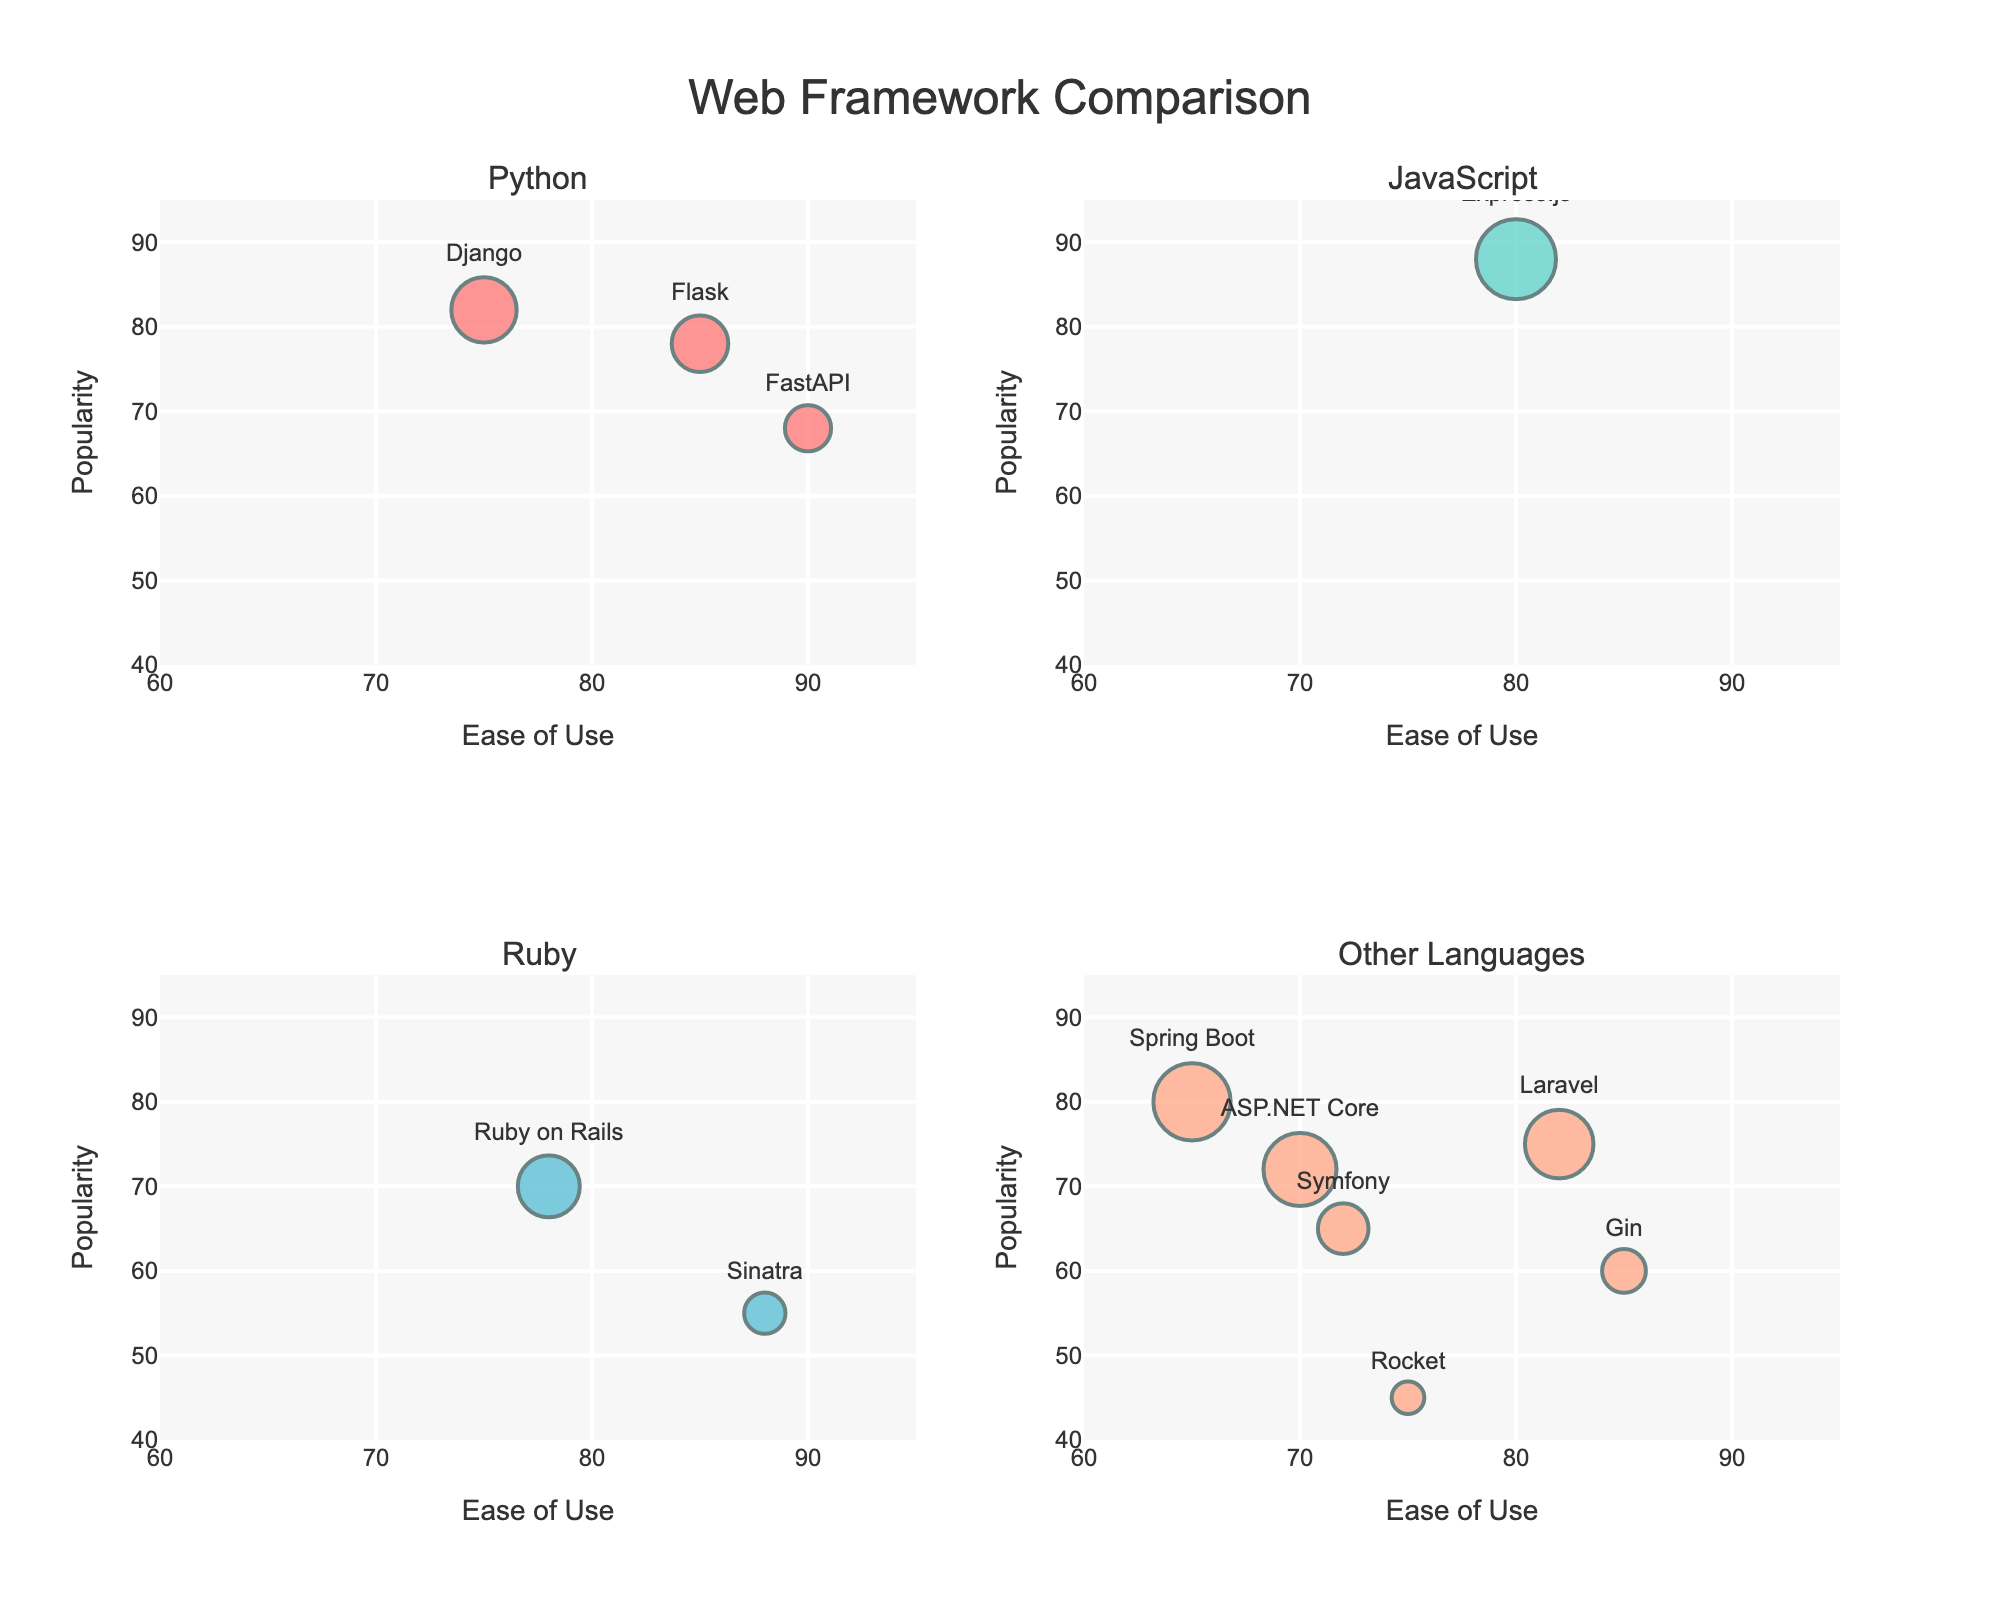What is the title of the figure? The title is located at the top center of the figure. It states the main topic represented by the visual data.
Answer: Web Framework Comparison Which frameworks are grouped under the Ruby language? In the subplot titled 'Ruby', identify the text labels inside the bubbles.
Answer: Ruby on Rails, Sinatra Among the frameworks using Python, which has the highest ease of use? In the subplot titled 'Python', compare ease-of-use values by looking at the x-axis positions.
Answer: FastAPI Which framework has the largest bubble in the JavaScript subplot? Locate the subplot titled 'JavaScript' and identify the framework with the largest bubble, indicating the largest community size.
Answer: Express.js What is the relationship between ease of use and popularity for Django? Find Django in the subplot titled 'Python' and note its x-axis (ease of use) and y-axis (popularity) positions to describe the relationship.
Answer: Ease of use: 75, Popularity: 82 How does Flask's community size compare to Laravel's? Compare the size of the bubbles representing Flask in the 'Python' subplot and Laravel in the 'Other Languages' subplot by referring to the size description.
Answer: Flask's community size is smaller than Laravel's Which framework has the lowest popularity in all subplots? Identify the bubble that is lowest on the y-axis across all subplots.
Answer: Rocket How are frameworks categorized in the figure? Describe the criteria used to plot frameworks in different subplots based on their programming language.
Answer: By programming language: Python, JavaScript, Ruby, and other languages Which of the Ruby frameworks has a higher ease of use? Compare the x-axis positions of Ruby on Rails and Sinatra in the 'Ruby' subplot.
Answer: Sinatra What is the general trend between community size and bubble size? Describe how the size of bubbles varies with the community size based on the visual representation.
Answer: Larger community size correlates with larger bubble size 